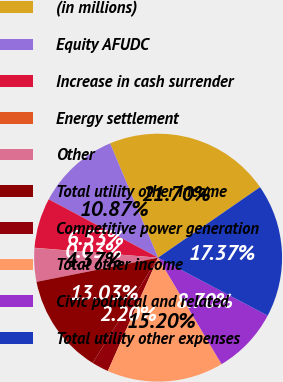Convert chart to OTSL. <chart><loc_0><loc_0><loc_500><loc_500><pie_chart><fcel>(in millions)<fcel>Equity AFUDC<fcel>Increase in cash surrender<fcel>Energy settlement<fcel>Other<fcel>Total utility other income<fcel>Competitive power generation<fcel>Total other income<fcel>Civic political and related<fcel>Total utility other expenses<nl><fcel>21.7%<fcel>10.87%<fcel>6.53%<fcel>0.03%<fcel>4.37%<fcel>13.03%<fcel>2.2%<fcel>15.2%<fcel>8.7%<fcel>17.37%<nl></chart> 